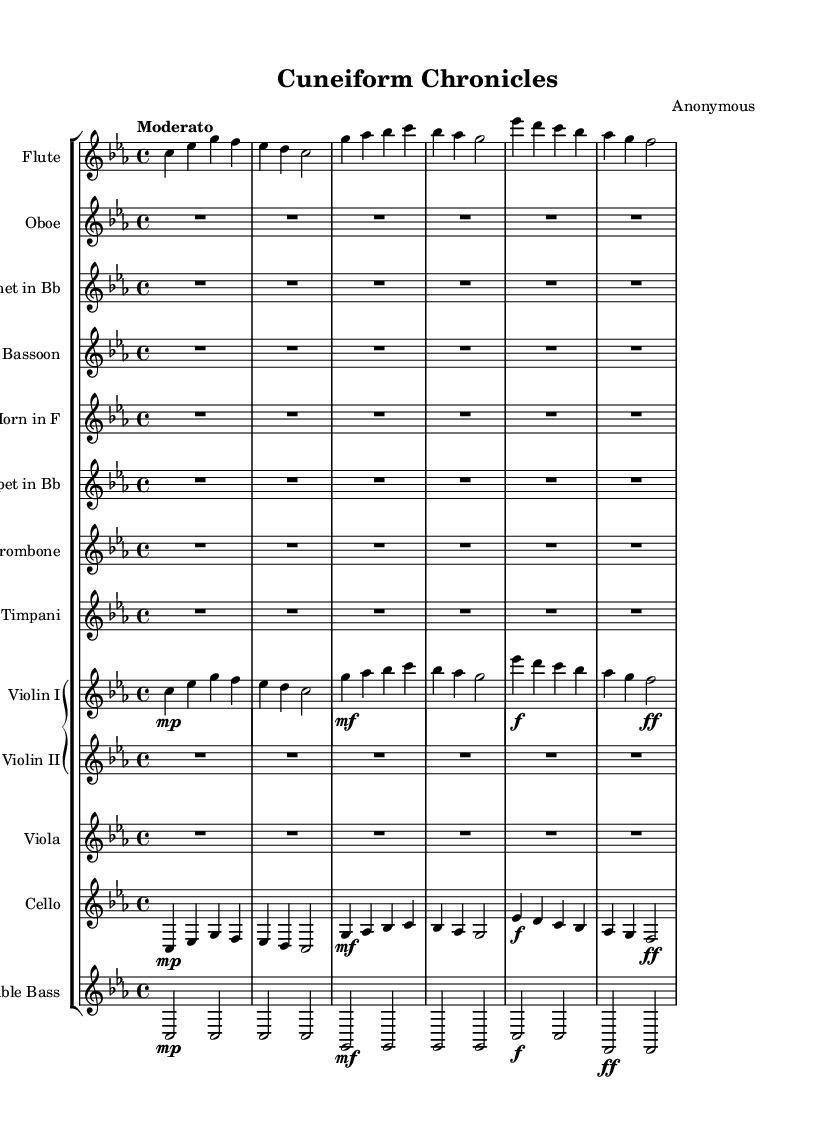What is the key signature of this symphony? The key signature is C minor, which has three flats. It can be identified by looking at the left side of the staff where the key signature is indicated.
Answer: C minor What is the time signature of this piece? The time signature is 4/4, which is indicated at the beginning of the score. This means there are four beats in each measure and the quarter note gets one beat.
Answer: 4/4 What is the tempo marking for the symphony? The tempo marking is "Moderato," which suggests a moderate pace for the music. It is usually found just above the first staff of the score.
Answer: Moderato Which instrument plays the main theme in the opening measures? The flute plays the main theme in the opening measures, as it is the first instrument to have notes written in the score.
Answer: Flute How many measures are used in the flute part before a rest occurs? The flute part has 6 measures before a rest occurs. This can be determined by counting the number of measures written until the first rest symbol.
Answer: 6 Which instruments have a rest for the entire piece? The Oboe, Clarinet, Bassoon, Horn, Trumpet, Trombone, and Timpani have rests for the entirety of the piece, as they have no notes written for the entire duration of the score.
Answer: Oboe, Clarinet, Bassoon, Horn, Trumpet, Trombone, Timpani 